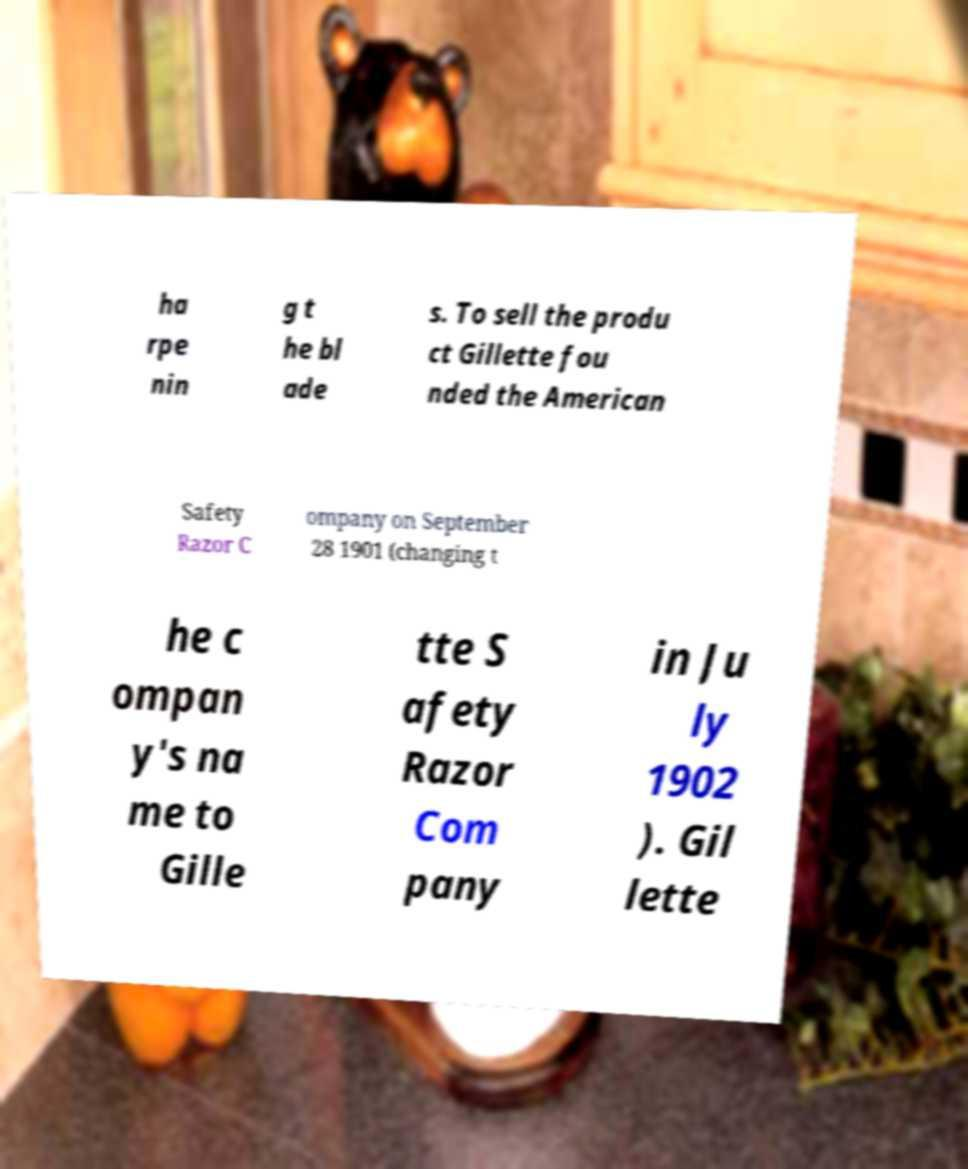Could you assist in decoding the text presented in this image and type it out clearly? ha rpe nin g t he bl ade s. To sell the produ ct Gillette fou nded the American Safety Razor C ompany on September 28 1901 (changing t he c ompan y's na me to Gille tte S afety Razor Com pany in Ju ly 1902 ). Gil lette 